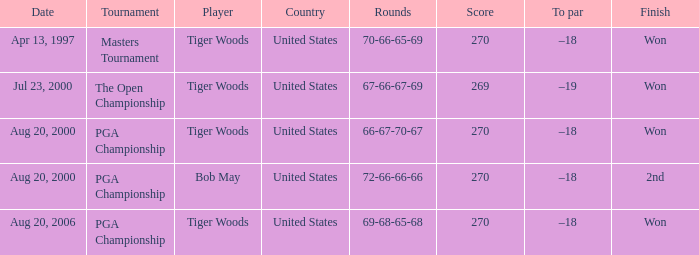Give me the full table as a dictionary. {'header': ['Date', 'Tournament', 'Player', 'Country', 'Rounds', 'Score', 'To par', 'Finish'], 'rows': [['Apr 13, 1997', 'Masters Tournament', 'Tiger Woods', 'United States', '70-66-65-69', '270', '–18', 'Won'], ['Jul 23, 2000', 'The Open Championship', 'Tiger Woods', 'United States', '67-66-67-69', '269', '–19', 'Won'], ['Aug 20, 2000', 'PGA Championship', 'Tiger Woods', 'United States', '66-67-70-67', '270', '–18', 'Won'], ['Aug 20, 2000', 'PGA Championship', 'Bob May', 'United States', '72-66-66-66', '270', '–18', '2nd'], ['Aug 20, 2006', 'PGA Championship', 'Tiger Woods', 'United States', '69-68-65-68', '270', '–18', 'Won']]} What country hosts the tournament the open championship? United States. 